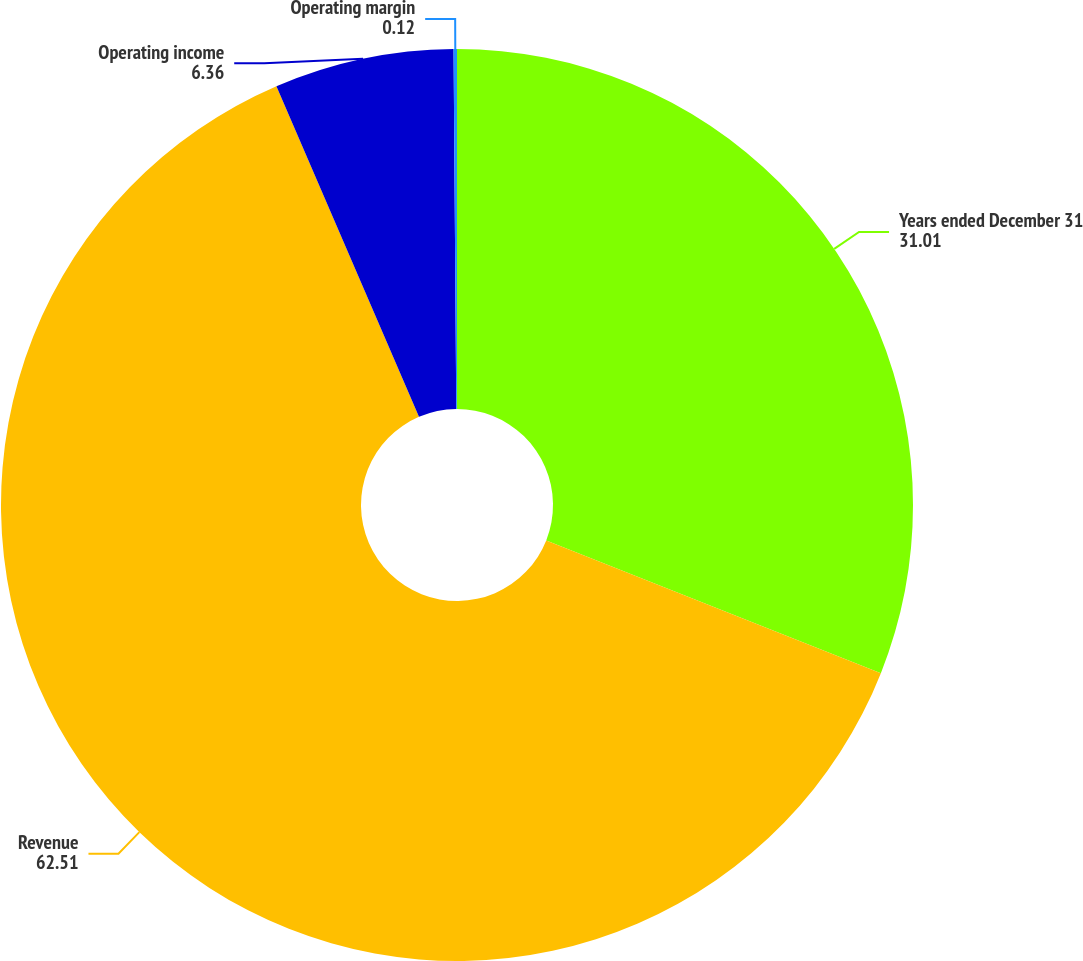<chart> <loc_0><loc_0><loc_500><loc_500><pie_chart><fcel>Years ended December 31<fcel>Revenue<fcel>Operating income<fcel>Operating margin<nl><fcel>31.01%<fcel>62.51%<fcel>6.36%<fcel>0.12%<nl></chart> 